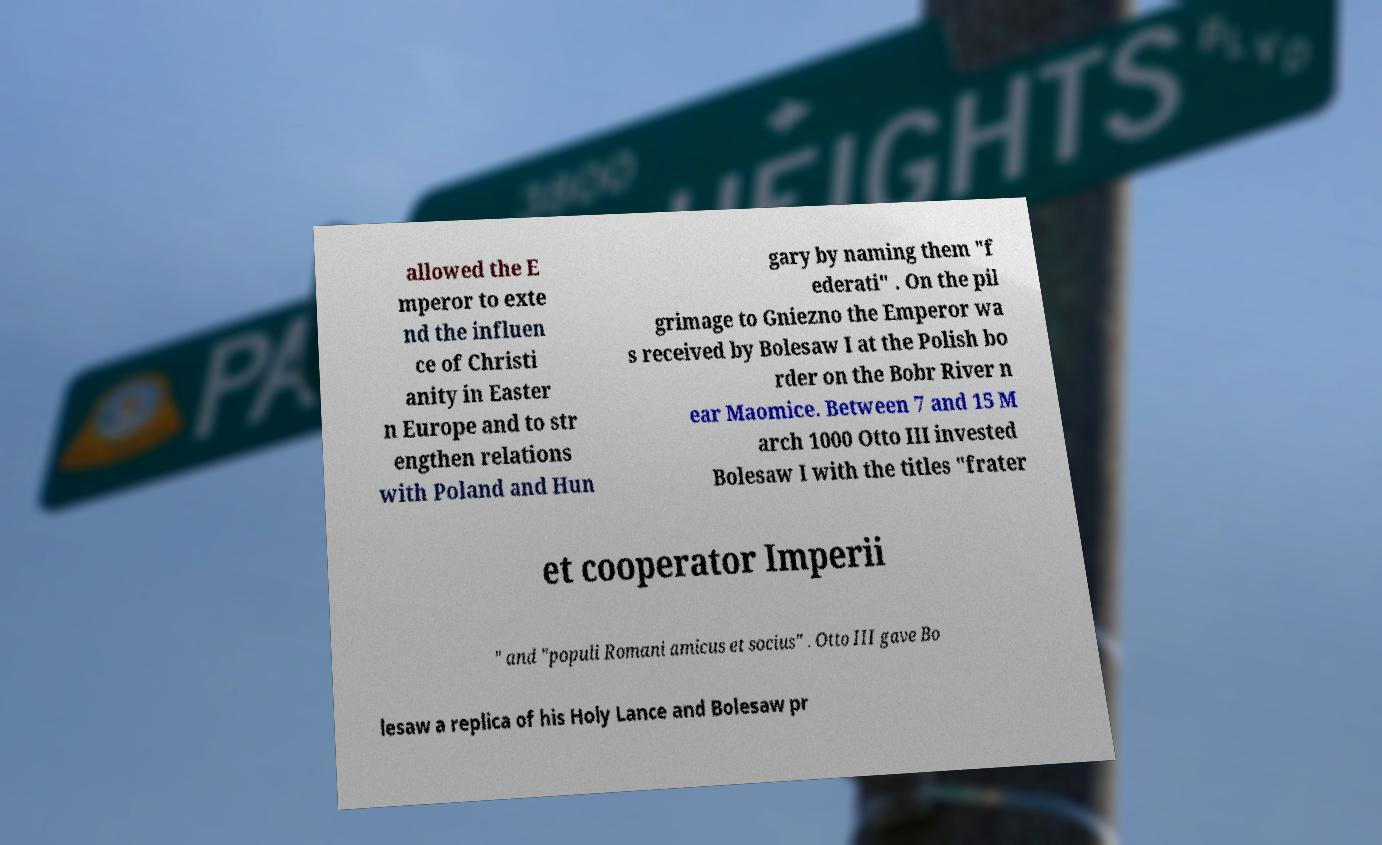Can you accurately transcribe the text from the provided image for me? allowed the E mperor to exte nd the influen ce of Christi anity in Easter n Europe and to str engthen relations with Poland and Hun gary by naming them "f ederati" . On the pil grimage to Gniezno the Emperor wa s received by Bolesaw I at the Polish bo rder on the Bobr River n ear Maomice. Between 7 and 15 M arch 1000 Otto III invested Bolesaw I with the titles "frater et cooperator Imperii " and "populi Romani amicus et socius" . Otto III gave Bo lesaw a replica of his Holy Lance and Bolesaw pr 